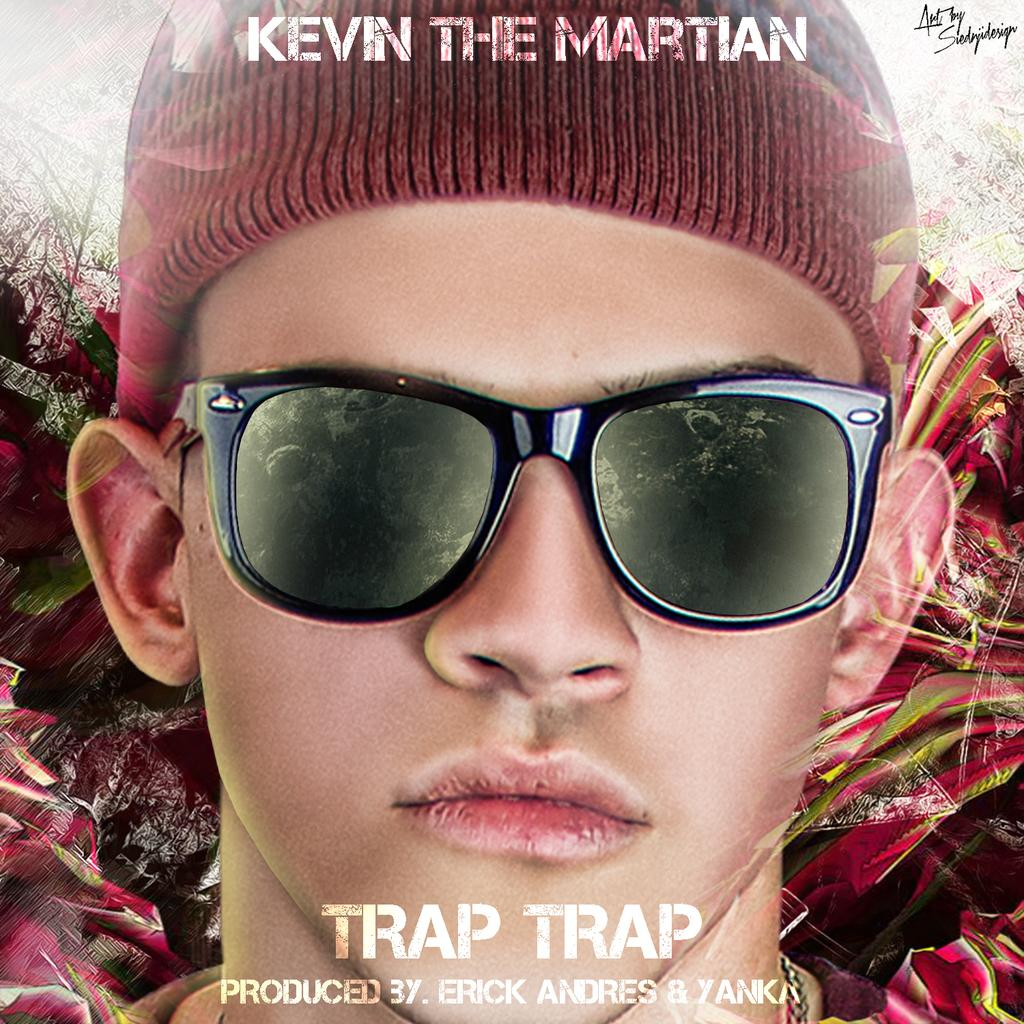<image>
Give a short and clear explanation of the subsequent image. a poster with a title on it that says 'trap trap' 